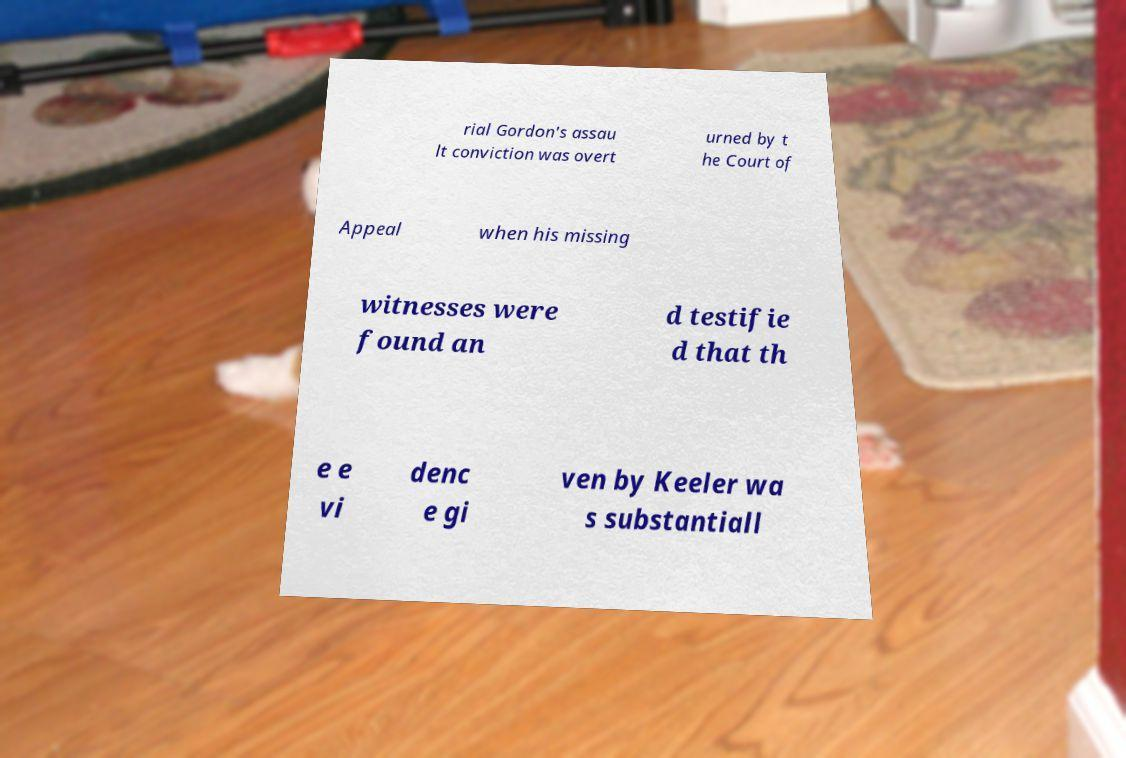For documentation purposes, I need the text within this image transcribed. Could you provide that? rial Gordon's assau lt conviction was overt urned by t he Court of Appeal when his missing witnesses were found an d testifie d that th e e vi denc e gi ven by Keeler wa s substantiall 